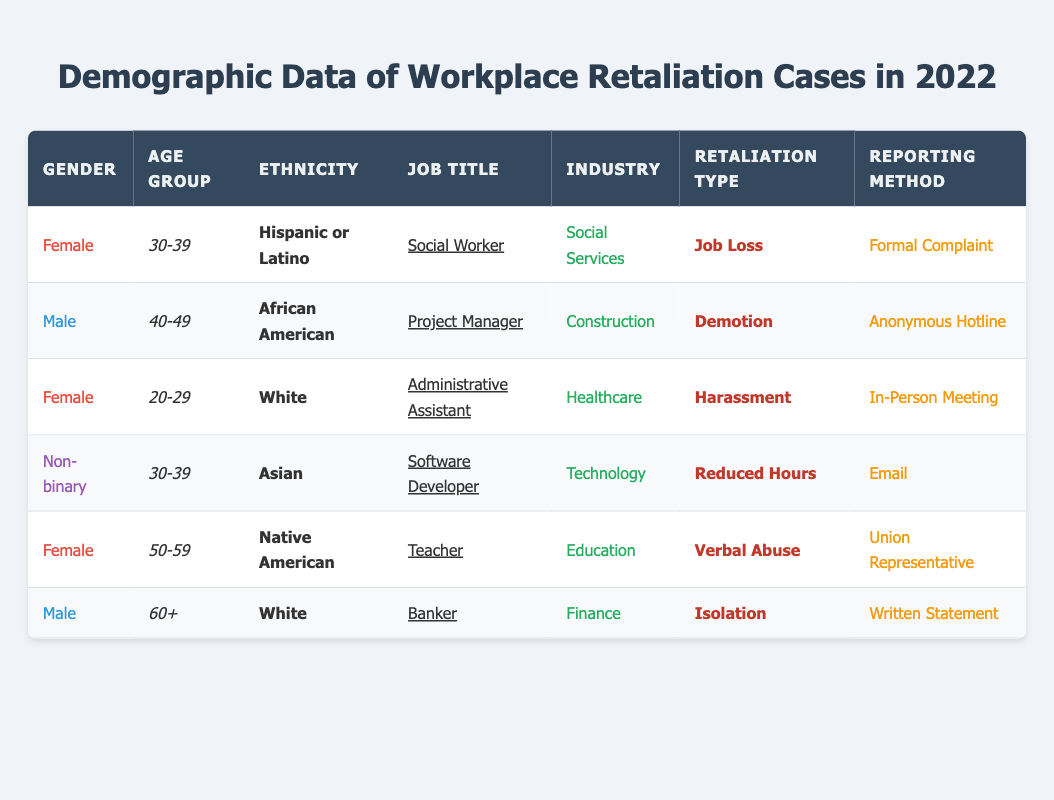What is the job title of the individual who reported job loss? Looking at the table, the only individual with the retaliation type "Job Loss" is listed as a Female Social Worker in the age group 30-39 from the Hispanic or Latino ethnicity.
Answer: Social Worker How many individuals reported harassment in 2022? According to the table, there is one individual who reported "Harassment" as the retaliation type, specifically the Female Administrative Assistant from the age group 20-29.
Answer: 1 What is the average age group of those reporting workplace retaliation incidents? The table shows the age groups: 30-39, 40-49, 20-29, 30-39, 50-59, and 60+. Counting the unique age groups gives us a better understanding of the diversity present; however, since they are categorically grouped, we consider the average as the middle of these ranges.
Answer: 40-49 Did any individuals report reduced hours? Yes, there is one individual in the table with the retaliation type "Reduced Hours," identifying as a Non-binary Software Developer from the age group 30-39.
Answer: Yes What is the industry of the individual who reported isolation? The individual who reported "Isolation" is a Male Banker from the Finance industry, as indicated in the table.
Answer: Finance What is the most common job title among those reporting workplace retaliation? The job titles listed are Social Worker, Project Manager, Administrative Assistant, Software Developer, Teacher, and Banker. There are two individuals identified as "Female" with the job title "Social Worker" and "Teacher"; however, no other job title appears more than once. Thus, the most often mentioned job title in this small data set is "Social Worker."
Answer: Social Worker How many individuals reported using a formal method of reporting? From the table, we see that only one individual used the "Formal Complaint" method, which was by the Female Social Worker.
Answer: 1 Is there a report of verbal abuse in any of the incidents? Yes, the table indicates that a Female Teacher from the Native American ethnicity experienced "Verbal Abuse" retaliation.
Answer: Yes Which age group reported the highest number of workplace incidents? Examining the table, the age group 30-39 appears twice (for Job Loss and Reduced Hours), while other age groups appear only once. Therefore, the age group with the most retaliation incident reports is 30-39.
Answer: 30-39 